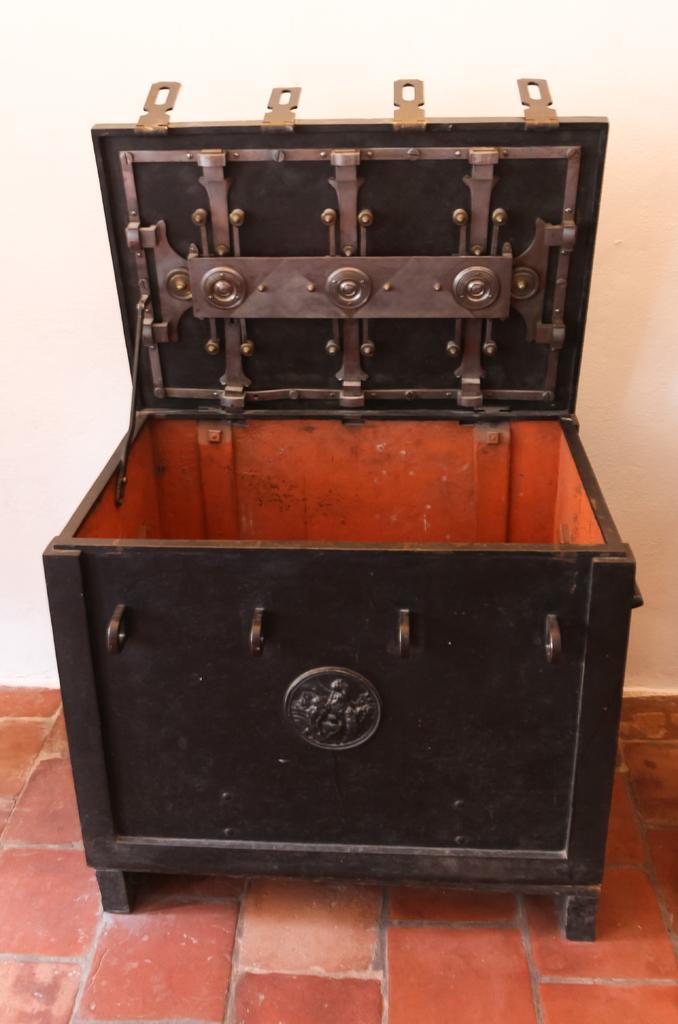Describe this image in one or two sentences. In the center of the picture there is a wooden box. At the bottom it is floor. In the background it is wall painted white. 